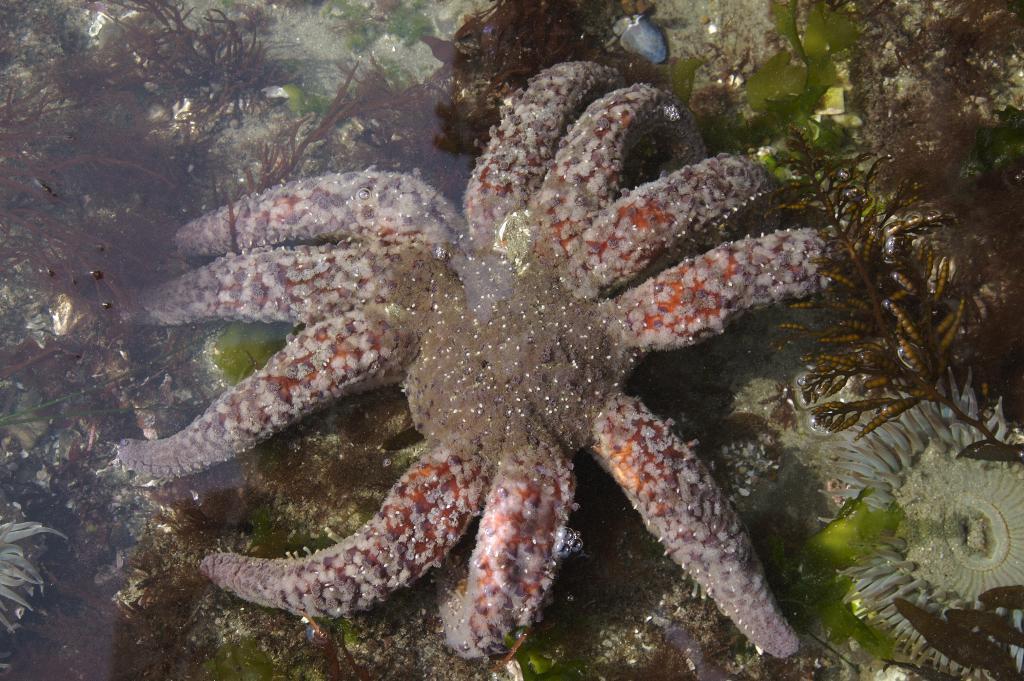How would you summarize this image in a sentence or two? There is a starfish in the water. Also there are plants in the water. 